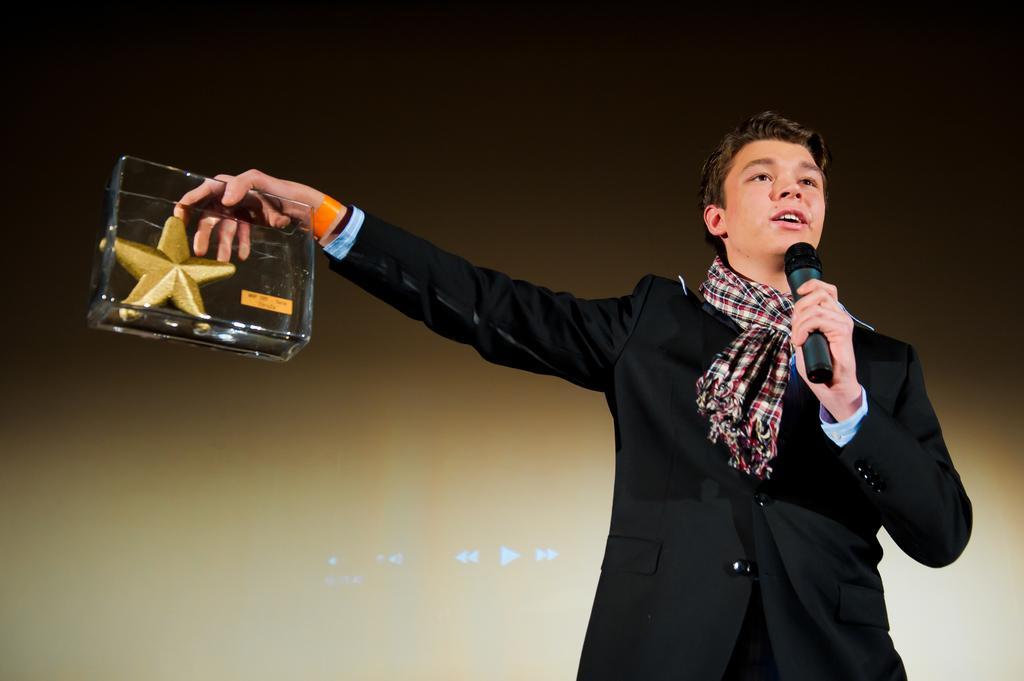How would you summarize this image in a sentence or two? On the right side of the image a man is standing and he is holding a mic and a box with a golden starfish in his hands. In the background there is a screen. 